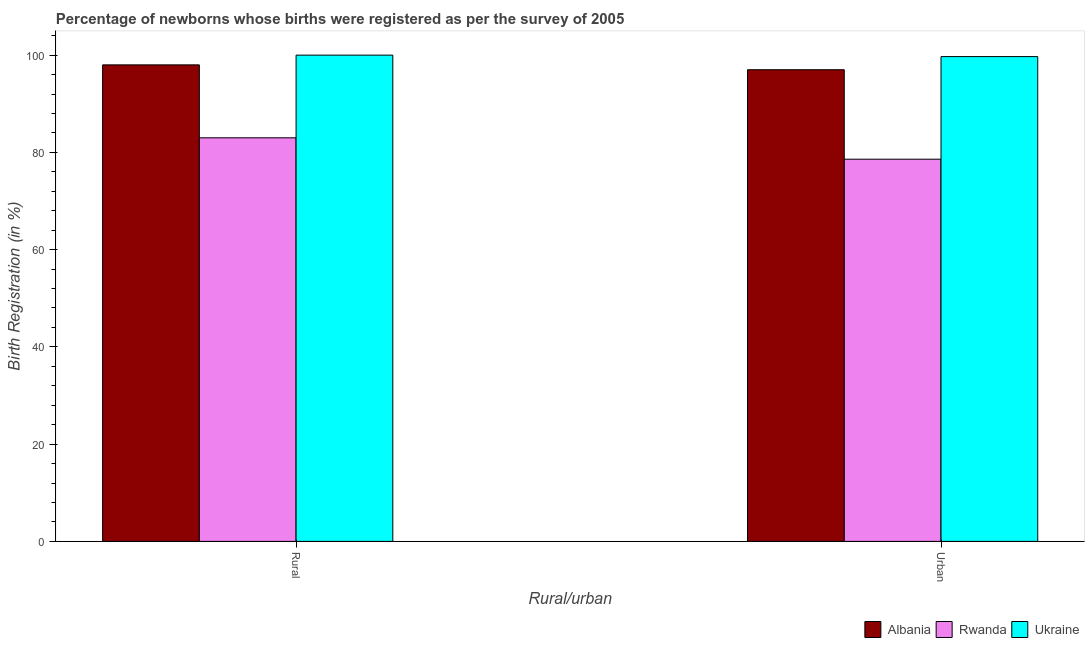How many different coloured bars are there?
Offer a terse response. 3. How many groups of bars are there?
Make the answer very short. 2. How many bars are there on the 1st tick from the right?
Ensure brevity in your answer.  3. What is the label of the 2nd group of bars from the left?
Ensure brevity in your answer.  Urban. What is the urban birth registration in Ukraine?
Provide a short and direct response. 99.7. Across all countries, what is the maximum urban birth registration?
Provide a short and direct response. 99.7. Across all countries, what is the minimum rural birth registration?
Your answer should be very brief. 83. In which country was the rural birth registration maximum?
Keep it short and to the point. Ukraine. In which country was the urban birth registration minimum?
Your answer should be compact. Rwanda. What is the total urban birth registration in the graph?
Give a very brief answer. 275.3. What is the difference between the rural birth registration in Albania and that in Ukraine?
Give a very brief answer. -2. What is the average rural birth registration per country?
Offer a terse response. 93.67. What is the difference between the urban birth registration and rural birth registration in Ukraine?
Keep it short and to the point. -0.3. In how many countries, is the urban birth registration greater than 56 %?
Provide a short and direct response. 3. What is the ratio of the urban birth registration in Ukraine to that in Albania?
Your answer should be very brief. 1.03. Is the rural birth registration in Ukraine less than that in Albania?
Give a very brief answer. No. What does the 1st bar from the left in Urban represents?
Provide a short and direct response. Albania. What does the 1st bar from the right in Rural represents?
Your answer should be very brief. Ukraine. How many bars are there?
Provide a short and direct response. 6. Are all the bars in the graph horizontal?
Your answer should be compact. No. How many countries are there in the graph?
Offer a terse response. 3. What is the difference between two consecutive major ticks on the Y-axis?
Make the answer very short. 20. Are the values on the major ticks of Y-axis written in scientific E-notation?
Give a very brief answer. No. Where does the legend appear in the graph?
Ensure brevity in your answer.  Bottom right. How many legend labels are there?
Provide a short and direct response. 3. What is the title of the graph?
Offer a terse response. Percentage of newborns whose births were registered as per the survey of 2005. What is the label or title of the X-axis?
Your response must be concise. Rural/urban. What is the label or title of the Y-axis?
Provide a short and direct response. Birth Registration (in %). What is the Birth Registration (in %) in Albania in Urban?
Make the answer very short. 97. What is the Birth Registration (in %) in Rwanda in Urban?
Offer a terse response. 78.6. What is the Birth Registration (in %) of Ukraine in Urban?
Your answer should be very brief. 99.7. Across all Rural/urban, what is the maximum Birth Registration (in %) in Ukraine?
Keep it short and to the point. 100. Across all Rural/urban, what is the minimum Birth Registration (in %) in Albania?
Keep it short and to the point. 97. Across all Rural/urban, what is the minimum Birth Registration (in %) in Rwanda?
Your answer should be very brief. 78.6. Across all Rural/urban, what is the minimum Birth Registration (in %) of Ukraine?
Offer a terse response. 99.7. What is the total Birth Registration (in %) of Albania in the graph?
Ensure brevity in your answer.  195. What is the total Birth Registration (in %) in Rwanda in the graph?
Ensure brevity in your answer.  161.6. What is the total Birth Registration (in %) of Ukraine in the graph?
Your answer should be compact. 199.7. What is the difference between the Birth Registration (in %) in Albania in Rural and that in Urban?
Make the answer very short. 1. What is the difference between the Birth Registration (in %) in Rwanda in Rural and the Birth Registration (in %) in Ukraine in Urban?
Make the answer very short. -16.7. What is the average Birth Registration (in %) of Albania per Rural/urban?
Keep it short and to the point. 97.5. What is the average Birth Registration (in %) in Rwanda per Rural/urban?
Make the answer very short. 80.8. What is the average Birth Registration (in %) of Ukraine per Rural/urban?
Your answer should be very brief. 99.85. What is the difference between the Birth Registration (in %) in Albania and Birth Registration (in %) in Ukraine in Rural?
Your answer should be compact. -2. What is the difference between the Birth Registration (in %) in Albania and Birth Registration (in %) in Rwanda in Urban?
Make the answer very short. 18.4. What is the difference between the Birth Registration (in %) in Albania and Birth Registration (in %) in Ukraine in Urban?
Offer a very short reply. -2.7. What is the difference between the Birth Registration (in %) in Rwanda and Birth Registration (in %) in Ukraine in Urban?
Offer a terse response. -21.1. What is the ratio of the Birth Registration (in %) of Albania in Rural to that in Urban?
Offer a very short reply. 1.01. What is the ratio of the Birth Registration (in %) of Rwanda in Rural to that in Urban?
Provide a short and direct response. 1.06. What is the ratio of the Birth Registration (in %) in Ukraine in Rural to that in Urban?
Keep it short and to the point. 1. 